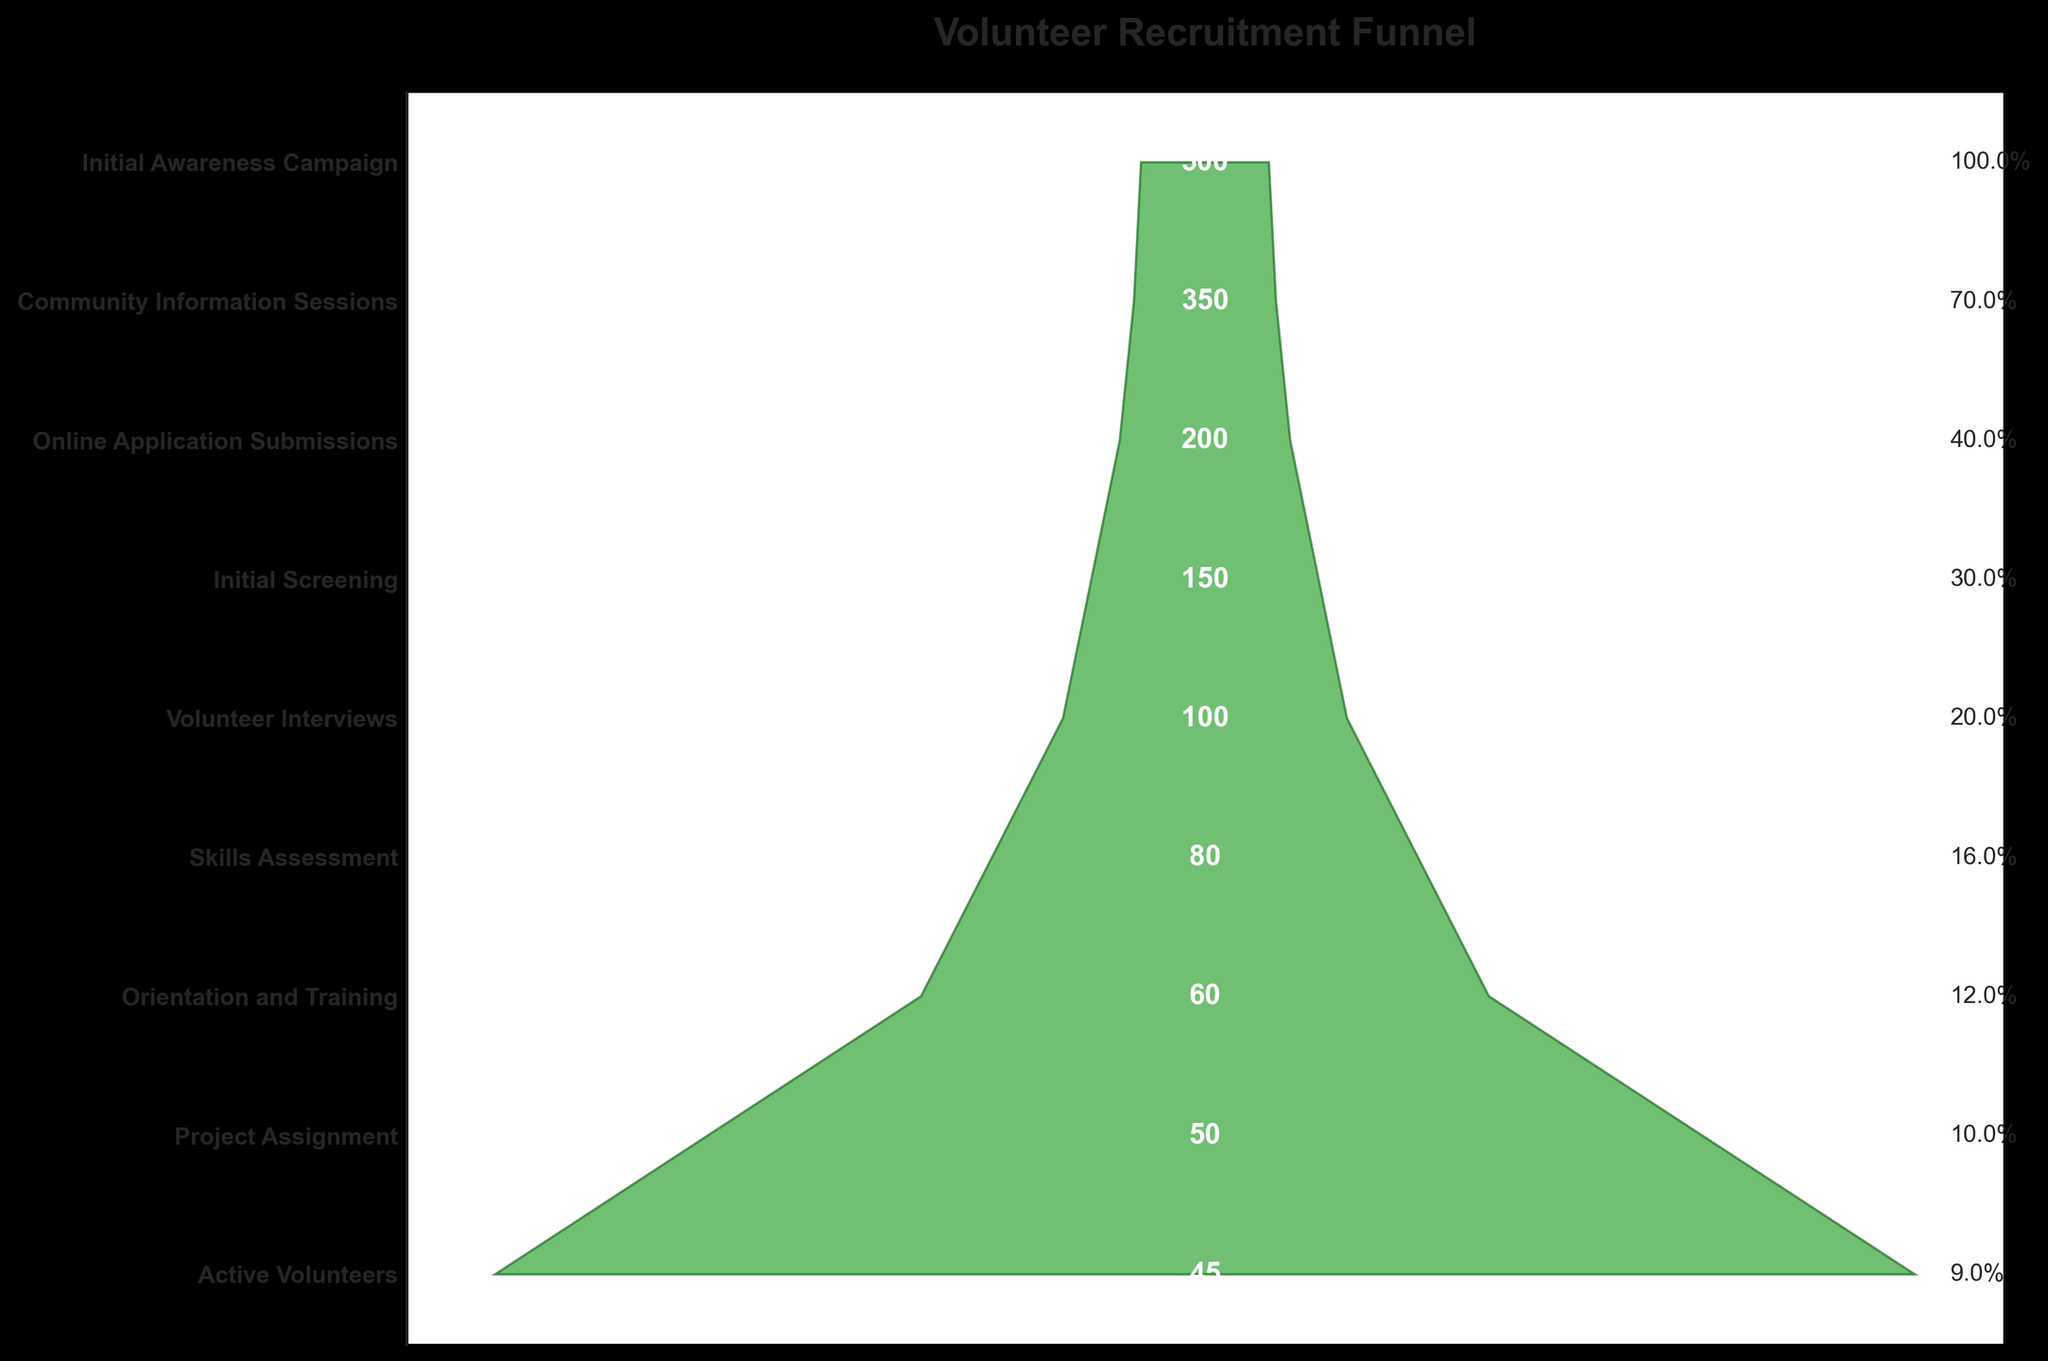How many stages are there in the volunteer recruitment process? There are titles listed in the y-axis of the funnel chart that represent different stages. By counting these titles, we can determine the number of stages.
Answer: 9 What is the percentage of people who submitted online applications relative to the initial awareness campaign? First, note the number of people in the initial awareness campaign (500) and those who submitted online applications (200). Calculate the percentage by (200 / 500) * 100.
Answer: 40% Which stage has the largest drop in the number of people compared to the previous stage? Examine the difference between successive stages' numbers. The largest drop is where this difference is greatest.
Answer: Community Information Sessions to Online Application Submissions How many people were assigned to projects out of those who underwent orientation and training? Refer to the numbers alongside these stages on the funnel chart. Orientation and Training has 60 people, and Project Assignment has 50 people.
Answer: 50 What stage comes immediately before initial screening? Check the y-axis labels from top to bottom. The stage listed just before Initial Screening (when going from top to bottom) is the one immediately prior.
Answer: Online Application Submissions What is the total number of people who reached the interview stage and beyond? Starting from the 'Volunteer Interviews' stage, sum the numbers of people at each subsequent stage: 100 (Volunteer Interviews) + 80 (Skills Assessment) + 60 (Orientation and Training) + 50 (Project Assignment) + 45 (Active Volunteers).
Answer: 335 At which stage does the figure show the first drop below 100 participants? Review the numbers associated with each stage from the top. The first instance where the number drops below 100 is at the Skills Assessment stage.
Answer: Skills Assessment How much percentage of people were retained from the Orientation and Training stage to the Active Volunteers stage? First, note that the Orientation and Training stage has 60 participants and the Active Volunteers stage has 45. Calculate (45 / 60) * 100 to get the percentage retained.
Answer: 75% How many people proceed from the initial screening to the interview process? Look at the numbers associated with these stages. Initial Screening has 150 people and Volunteer Interviews has 100.
Answer: 100 